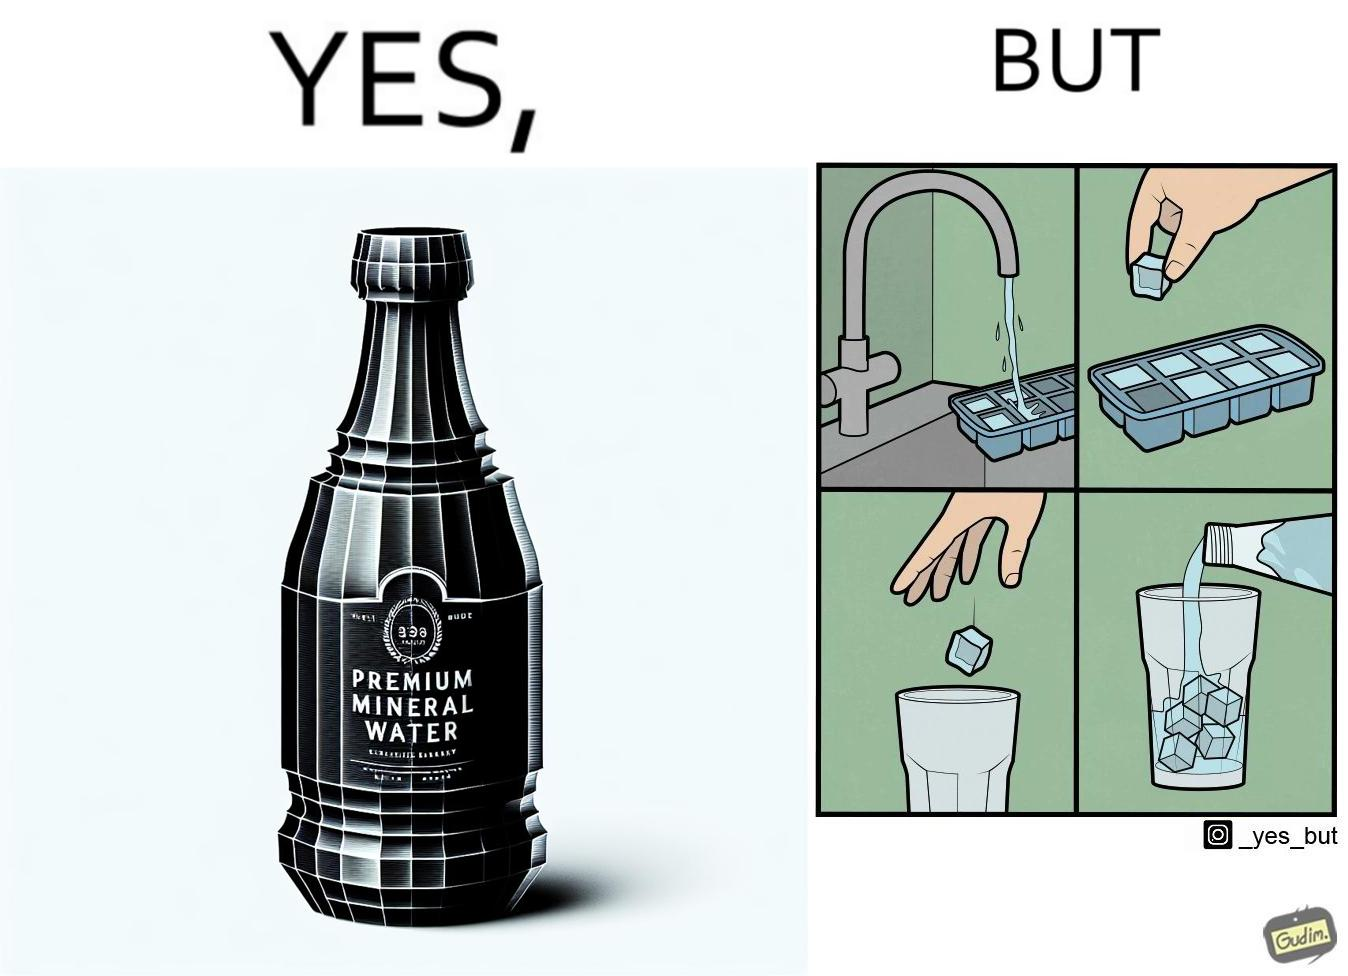Describe the content of this image. This image is ironical, as a bottle of mineral water is being used along with ice cubes from tap water, while the sama tap water could have been instead used. 